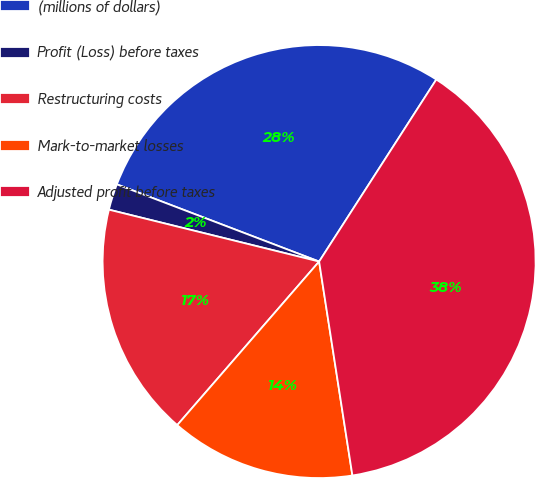Convert chart to OTSL. <chart><loc_0><loc_0><loc_500><loc_500><pie_chart><fcel>(millions of dollars)<fcel>Profit (Loss) before taxes<fcel>Restructuring costs<fcel>Mark-to-market losses<fcel>Adjusted profit before taxes<nl><fcel>28.3%<fcel>1.95%<fcel>17.48%<fcel>13.83%<fcel>38.44%<nl></chart> 